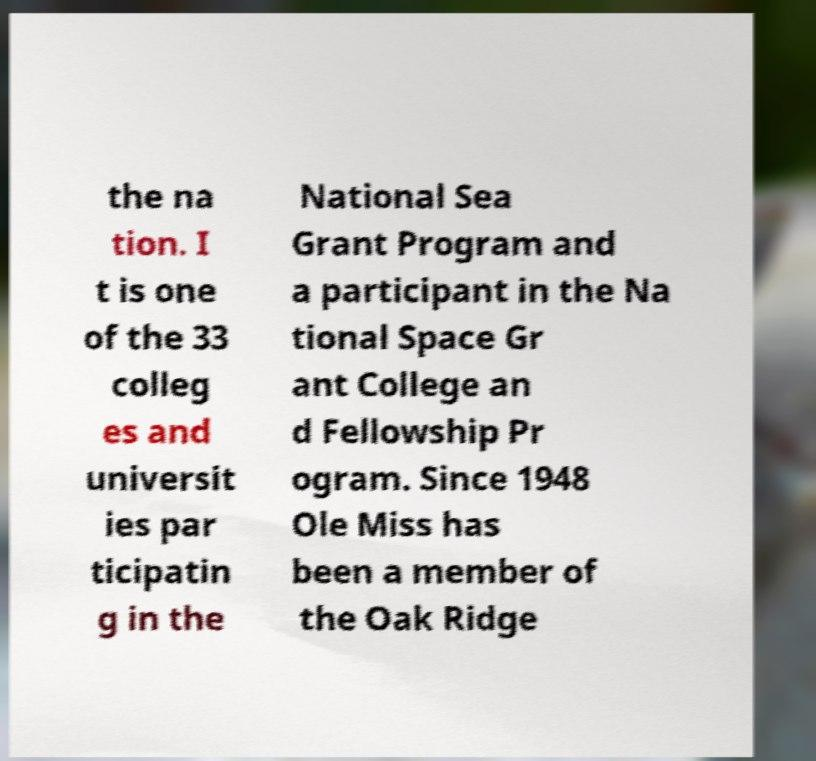I need the written content from this picture converted into text. Can you do that? the na tion. I t is one of the 33 colleg es and universit ies par ticipatin g in the National Sea Grant Program and a participant in the Na tional Space Gr ant College an d Fellowship Pr ogram. Since 1948 Ole Miss has been a member of the Oak Ridge 